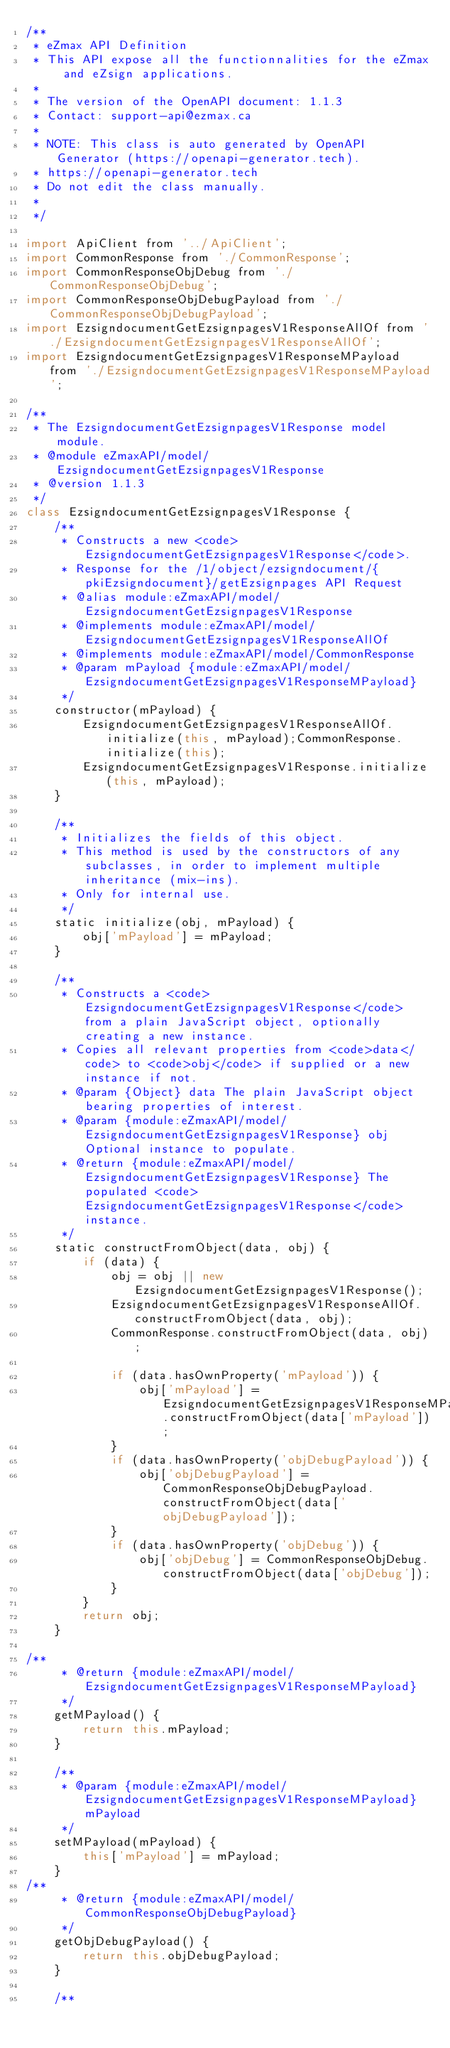Convert code to text. <code><loc_0><loc_0><loc_500><loc_500><_JavaScript_>/**
 * eZmax API Definition
 * This API expose all the functionnalities for the eZmax and eZsign applications.
 *
 * The version of the OpenAPI document: 1.1.3
 * Contact: support-api@ezmax.ca
 *
 * NOTE: This class is auto generated by OpenAPI Generator (https://openapi-generator.tech).
 * https://openapi-generator.tech
 * Do not edit the class manually.
 *
 */

import ApiClient from '../ApiClient';
import CommonResponse from './CommonResponse';
import CommonResponseObjDebug from './CommonResponseObjDebug';
import CommonResponseObjDebugPayload from './CommonResponseObjDebugPayload';
import EzsigndocumentGetEzsignpagesV1ResponseAllOf from './EzsigndocumentGetEzsignpagesV1ResponseAllOf';
import EzsigndocumentGetEzsignpagesV1ResponseMPayload from './EzsigndocumentGetEzsignpagesV1ResponseMPayload';

/**
 * The EzsigndocumentGetEzsignpagesV1Response model module.
 * @module eZmaxAPI/model/EzsigndocumentGetEzsignpagesV1Response
 * @version 1.1.3
 */
class EzsigndocumentGetEzsignpagesV1Response {
    /**
     * Constructs a new <code>EzsigndocumentGetEzsignpagesV1Response</code>.
     * Response for the /1/object/ezsigndocument/{pkiEzsigndocument}/getEzsignpages API Request
     * @alias module:eZmaxAPI/model/EzsigndocumentGetEzsignpagesV1Response
     * @implements module:eZmaxAPI/model/EzsigndocumentGetEzsignpagesV1ResponseAllOf
     * @implements module:eZmaxAPI/model/CommonResponse
     * @param mPayload {module:eZmaxAPI/model/EzsigndocumentGetEzsignpagesV1ResponseMPayload} 
     */
    constructor(mPayload) { 
        EzsigndocumentGetEzsignpagesV1ResponseAllOf.initialize(this, mPayload);CommonResponse.initialize(this);
        EzsigndocumentGetEzsignpagesV1Response.initialize(this, mPayload);
    }

    /**
     * Initializes the fields of this object.
     * This method is used by the constructors of any subclasses, in order to implement multiple inheritance (mix-ins).
     * Only for internal use.
     */
    static initialize(obj, mPayload) { 
        obj['mPayload'] = mPayload;
    }

    /**
     * Constructs a <code>EzsigndocumentGetEzsignpagesV1Response</code> from a plain JavaScript object, optionally creating a new instance.
     * Copies all relevant properties from <code>data</code> to <code>obj</code> if supplied or a new instance if not.
     * @param {Object} data The plain JavaScript object bearing properties of interest.
     * @param {module:eZmaxAPI/model/EzsigndocumentGetEzsignpagesV1Response} obj Optional instance to populate.
     * @return {module:eZmaxAPI/model/EzsigndocumentGetEzsignpagesV1Response} The populated <code>EzsigndocumentGetEzsignpagesV1Response</code> instance.
     */
    static constructFromObject(data, obj) {
        if (data) {
            obj = obj || new EzsigndocumentGetEzsignpagesV1Response();
            EzsigndocumentGetEzsignpagesV1ResponseAllOf.constructFromObject(data, obj);
            CommonResponse.constructFromObject(data, obj);

            if (data.hasOwnProperty('mPayload')) {
                obj['mPayload'] = EzsigndocumentGetEzsignpagesV1ResponseMPayload.constructFromObject(data['mPayload']);
            }
            if (data.hasOwnProperty('objDebugPayload')) {
                obj['objDebugPayload'] = CommonResponseObjDebugPayload.constructFromObject(data['objDebugPayload']);
            }
            if (data.hasOwnProperty('objDebug')) {
                obj['objDebug'] = CommonResponseObjDebug.constructFromObject(data['objDebug']);
            }
        }
        return obj;
    }

/**
     * @return {module:eZmaxAPI/model/EzsigndocumentGetEzsignpagesV1ResponseMPayload}
     */
    getMPayload() {
        return this.mPayload;
    }

    /**
     * @param {module:eZmaxAPI/model/EzsigndocumentGetEzsignpagesV1ResponseMPayload} mPayload
     */
    setMPayload(mPayload) {
        this['mPayload'] = mPayload;
    }
/**
     * @return {module:eZmaxAPI/model/CommonResponseObjDebugPayload}
     */
    getObjDebugPayload() {
        return this.objDebugPayload;
    }

    /**</code> 